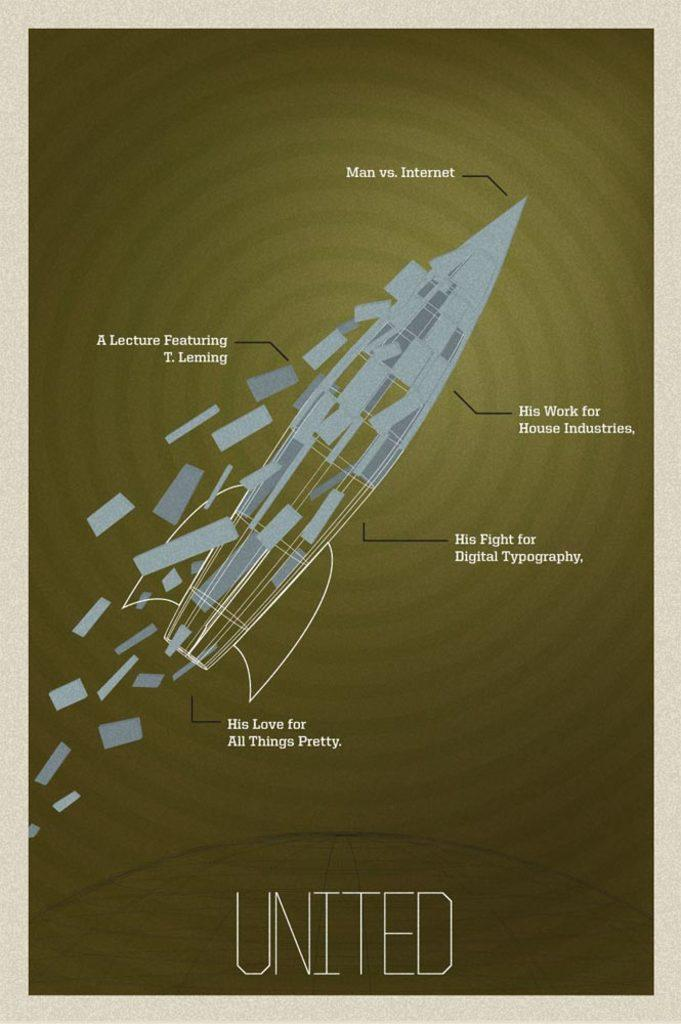<image>
Write a terse but informative summary of the picture. A picture of a deteriorating rocket with quotes written around it, for the brand United 